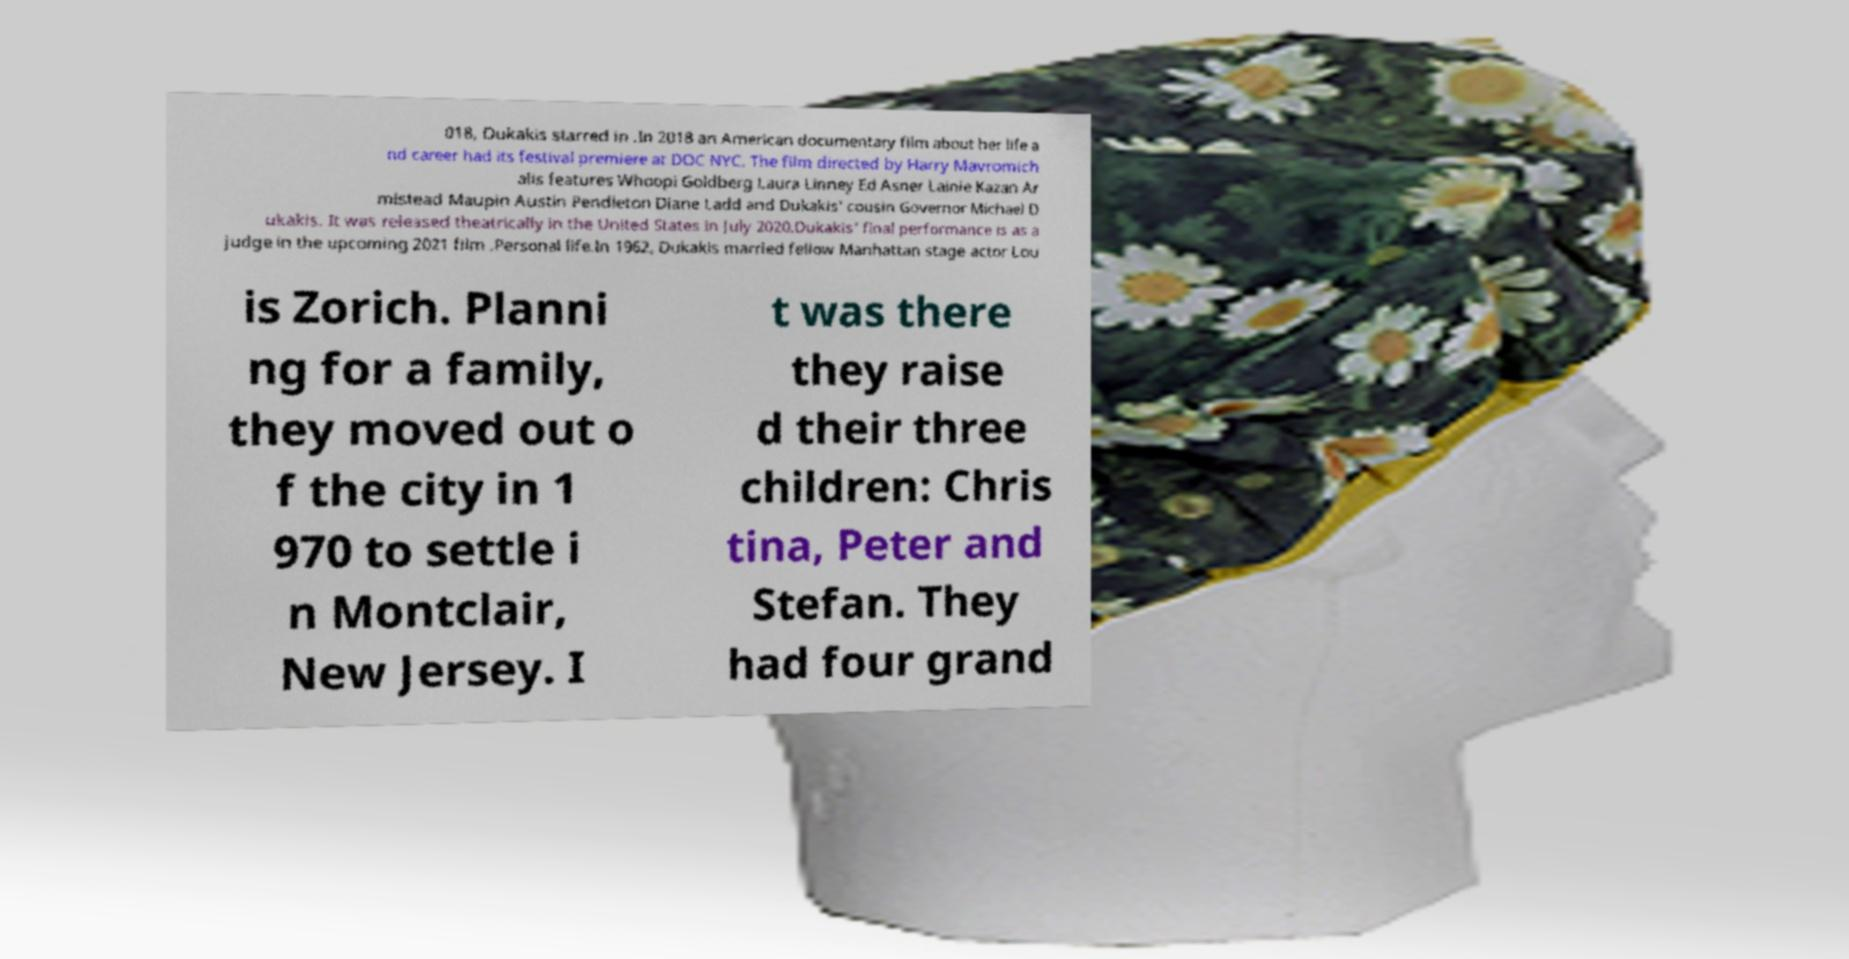Please identify and transcribe the text found in this image. 018, Dukakis starred in .In 2018 an American documentary film about her life a nd career had its festival premiere at DOC NYC. The film directed by Harry Mavromich alis features Whoopi Goldberg Laura Linney Ed Asner Lainie Kazan Ar mistead Maupin Austin Pendleton Diane Ladd and Dukakis' cousin Governor Michael D ukakis. It was released theatrically in the United States in July 2020.Dukakis' final performance is as a judge in the upcoming 2021 film .Personal life.In 1962, Dukakis married fellow Manhattan stage actor Lou is Zorich. Planni ng for a family, they moved out o f the city in 1 970 to settle i n Montclair, New Jersey. I t was there they raise d their three children: Chris tina, Peter and Stefan. They had four grand 